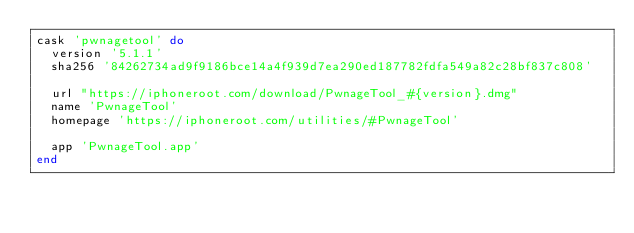Convert code to text. <code><loc_0><loc_0><loc_500><loc_500><_Ruby_>cask 'pwnagetool' do
  version '5.1.1'
  sha256 '84262734ad9f9186bce14a4f939d7ea290ed187782fdfa549a82c28bf837c808'

  url "https://iphoneroot.com/download/PwnageTool_#{version}.dmg"
  name 'PwnageTool'
  homepage 'https://iphoneroot.com/utilities/#PwnageTool'

  app 'PwnageTool.app'
end
</code> 